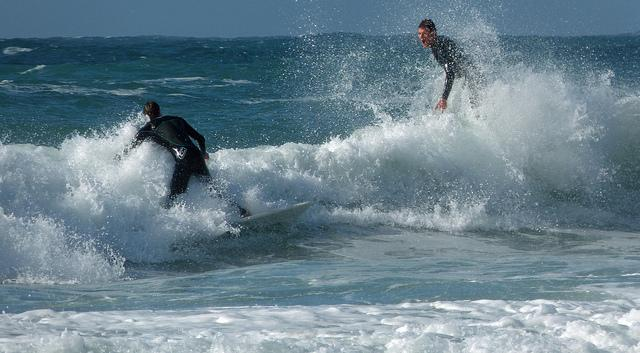Why is the surfer wearing a wetsuit? insulation 